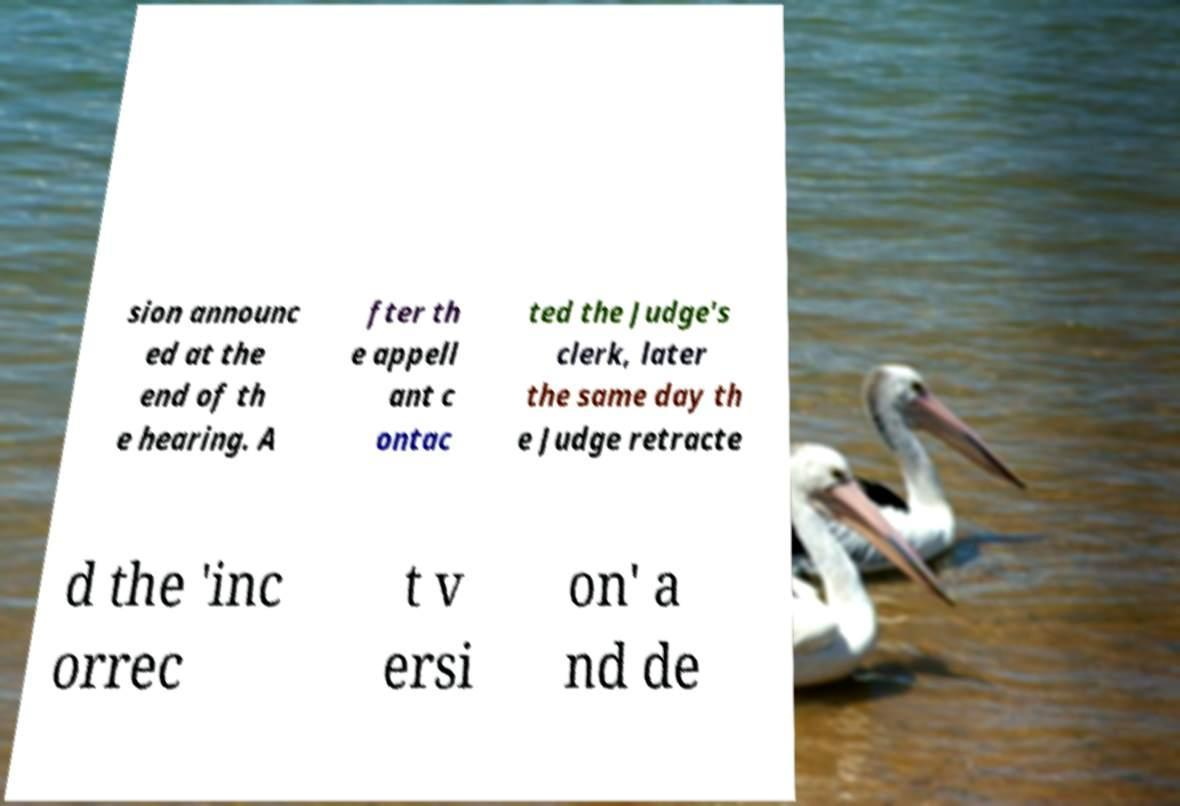Please read and relay the text visible in this image. What does it say? sion announc ed at the end of th e hearing. A fter th e appell ant c ontac ted the Judge's clerk, later the same day th e Judge retracte d the 'inc orrec t v ersi on' a nd de 